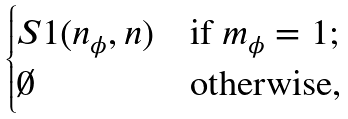Convert formula to latex. <formula><loc_0><loc_0><loc_500><loc_500>\begin{cases} S 1 ( n _ { \phi } , n ) & \text {if $m_{\phi} = 1$;} \\ \emptyset & \text {otherwise,} \end{cases}</formula> 